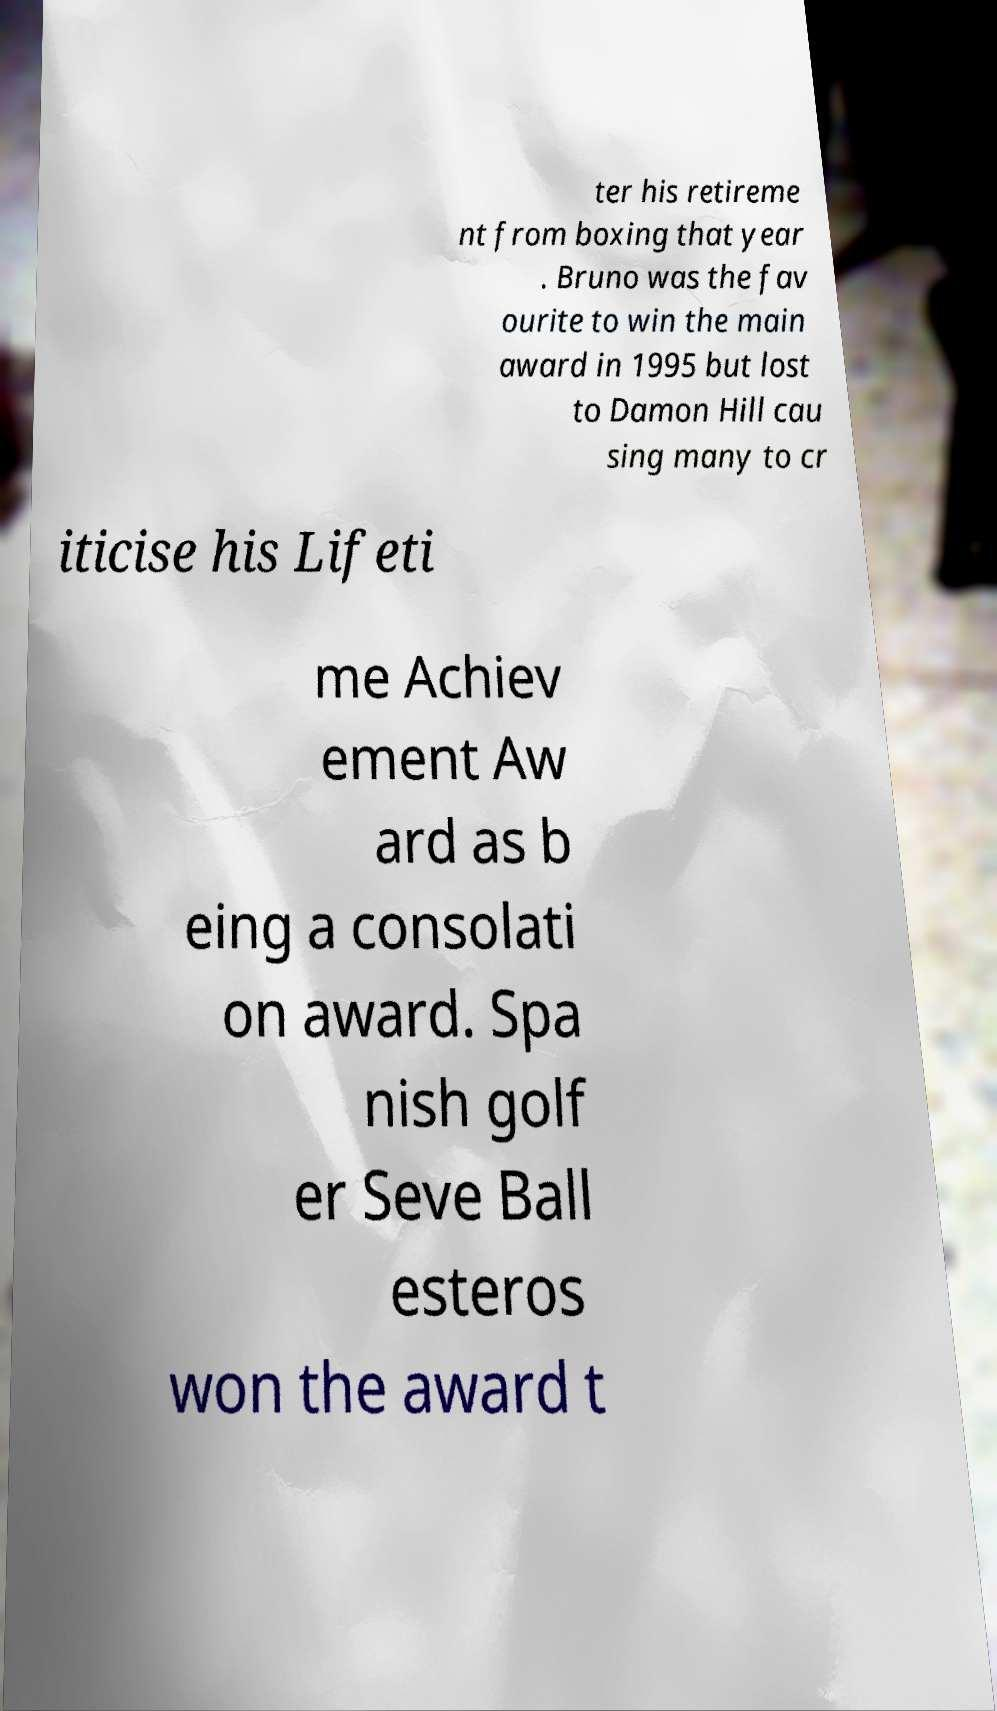What messages or text are displayed in this image? I need them in a readable, typed format. ter his retireme nt from boxing that year . Bruno was the fav ourite to win the main award in 1995 but lost to Damon Hill cau sing many to cr iticise his Lifeti me Achiev ement Aw ard as b eing a consolati on award. Spa nish golf er Seve Ball esteros won the award t 